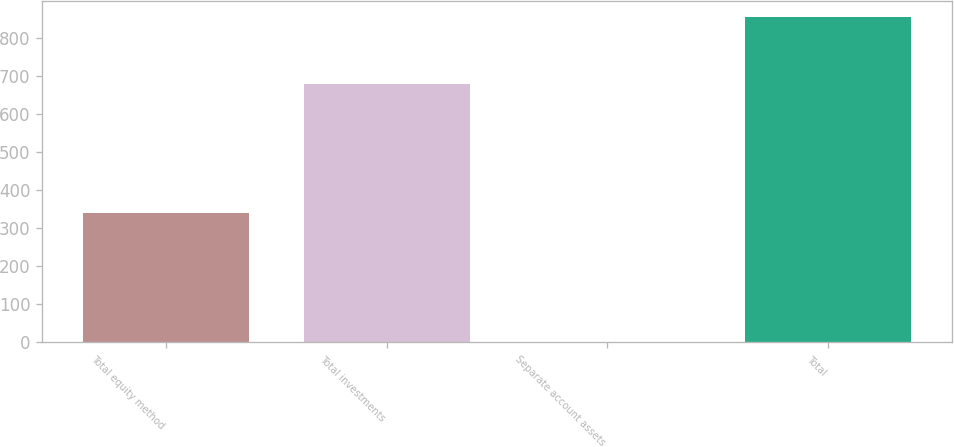Convert chart. <chart><loc_0><loc_0><loc_500><loc_500><bar_chart><fcel>Total equity method<fcel>Total investments<fcel>Separate account assets<fcel>Total<nl><fcel>339<fcel>679<fcel>2<fcel>855<nl></chart> 